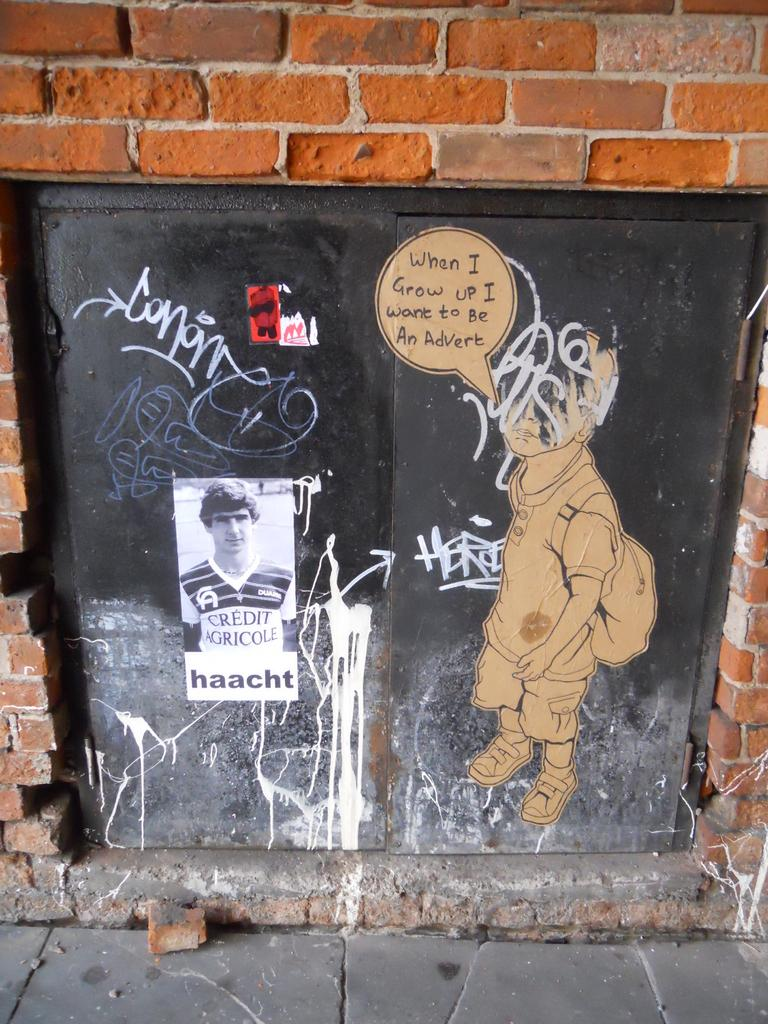What is the main subject of the image? There is a poster in the image. What is depicted on the poster? There is a picture of a person on the poster. Where can texts be found in the image? Texts are written on a metal door and a brick wall. How many jellyfish are swimming in the brick wall in the image? There are no jellyfish present in the image, and they cannot swim on a brick wall. What type of patch is sewn onto the metal door in the image? There is no patch present on the metal door in the image. 